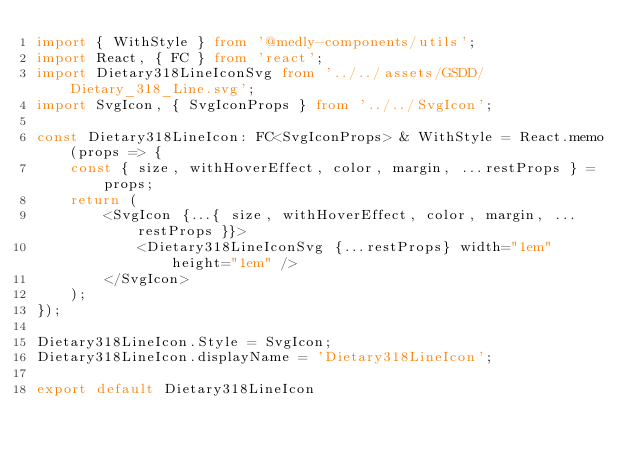Convert code to text. <code><loc_0><loc_0><loc_500><loc_500><_TypeScript_>import { WithStyle } from '@medly-components/utils';
import React, { FC } from 'react';
import Dietary318LineIconSvg from '../../assets/GSDD/Dietary_318_Line.svg';
import SvgIcon, { SvgIconProps } from '../../SvgIcon';

const Dietary318LineIcon: FC<SvgIconProps> & WithStyle = React.memo(props => {
    const { size, withHoverEffect, color, margin, ...restProps } = props;
    return (
        <SvgIcon {...{ size, withHoverEffect, color, margin, ...restProps }}>
            <Dietary318LineIconSvg {...restProps} width="1em" height="1em" />
        </SvgIcon>
    );
});

Dietary318LineIcon.Style = SvgIcon;
Dietary318LineIcon.displayName = 'Dietary318LineIcon';

export default Dietary318LineIcon
</code> 